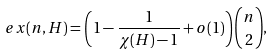<formula> <loc_0><loc_0><loc_500><loc_500>\ e x ( n , H ) = \left ( 1 - \frac { 1 } { \chi ( H ) - 1 } + o ( 1 ) \right ) \binom { n } { 2 } ,</formula> 